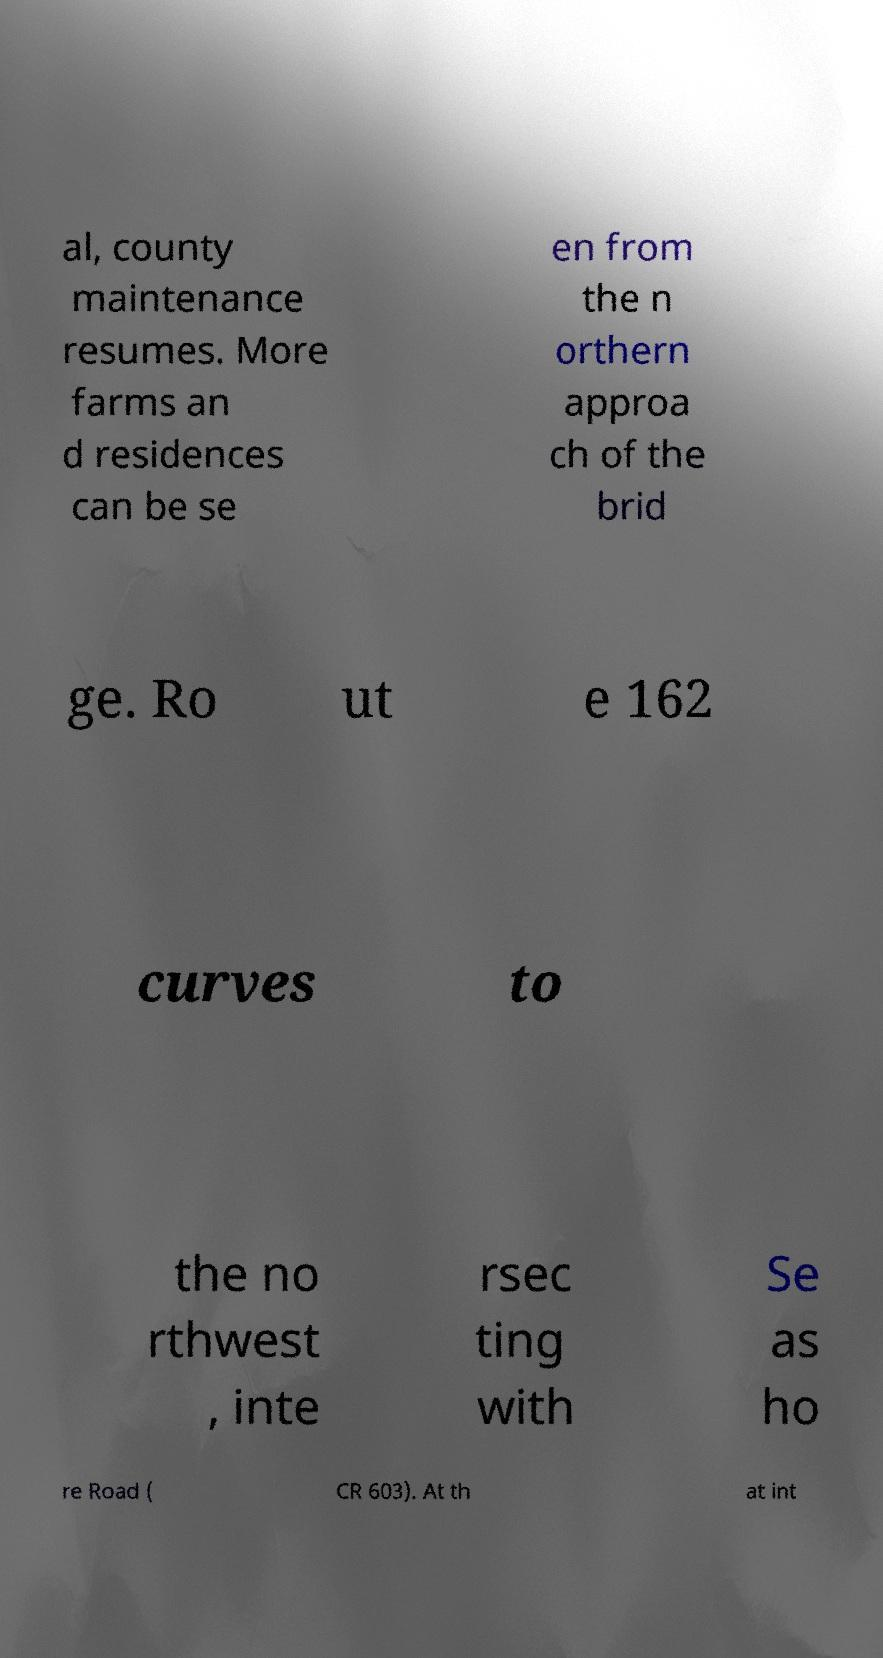Could you assist in decoding the text presented in this image and type it out clearly? al, county maintenance resumes. More farms an d residences can be se en from the n orthern approa ch of the brid ge. Ro ut e 162 curves to the no rthwest , inte rsec ting with Se as ho re Road ( CR 603). At th at int 